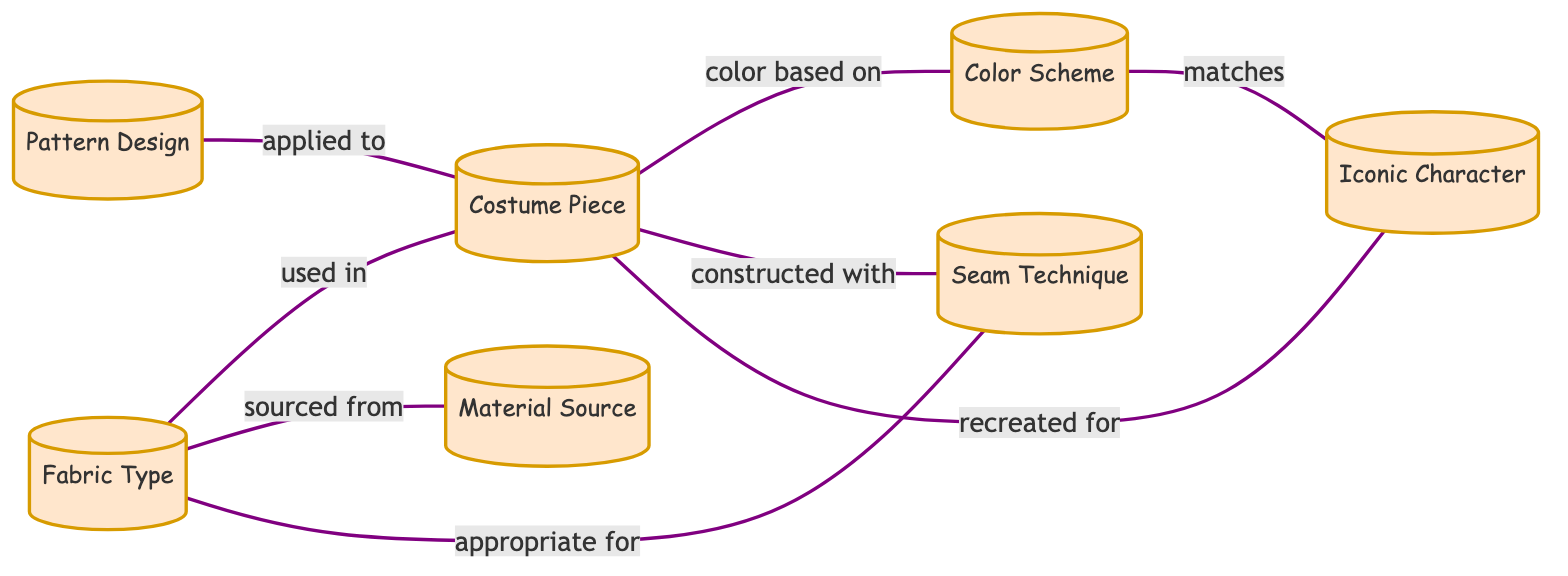What is the total number of nodes in the diagram? The nodes in the diagram are Fabric Type, Pattern Design, Costume Piece, Color Scheme, Seam Technique, Material Source, and Iconic Character. Counting these, there are seven distinct nodes.
Answer: 7 Which node is directly connected to Material Source? The edge from Material Source shows it is connected to Fabric Type, indicating that Material Source has a direct relationship with Fabric Type.
Answer: Fabric Type What label describes the relationship between Seam Technique and Fabric Type? The edge between Seam Technique and Fabric Type is labeled "appropriate for," which describes how Seam Technique relates to the type of fabric used.
Answer: appropriate for How many edges are in the graph? By examining the connection lines in the diagram, there are a total of eight edges, which represent the relationships between the nodes.
Answer: 8 What is the relationship between Costume Piece and Iconic Character? The edge shows that the relationship is indicated with "recreated for," meaning that the Costume Piece is specifically made for the Iconic Character.
Answer: recreated for Which node is color-based according to the diagram? The Costume Piece node connects to Color Scheme with the label "color based on," indicating that the Color Scheme is determined by the Costume Piece.
Answer: Color Scheme What does the Pattern Design apply to? The relationship shown by the edge indicates that the Pattern Design is applied to the Costume Piece, meaning that it is directly related to creating the Costume Piece.
Answer: Costume Piece Which nodes do Color Scheme and Iconic Character share a relationship with? Both Color Scheme and Iconic Character are connected to the Costume Piece. The Color Scheme is noted to match the Iconic Character as well. This indicates they share a common point of connection in the graph.
Answer: Costume Piece What do the edges represent in this undirected graph? The edges represent the relationships between the various nodes, indicating how the different components of costume creation are interdependent in the context of the diagram.
Answer: Relationships 